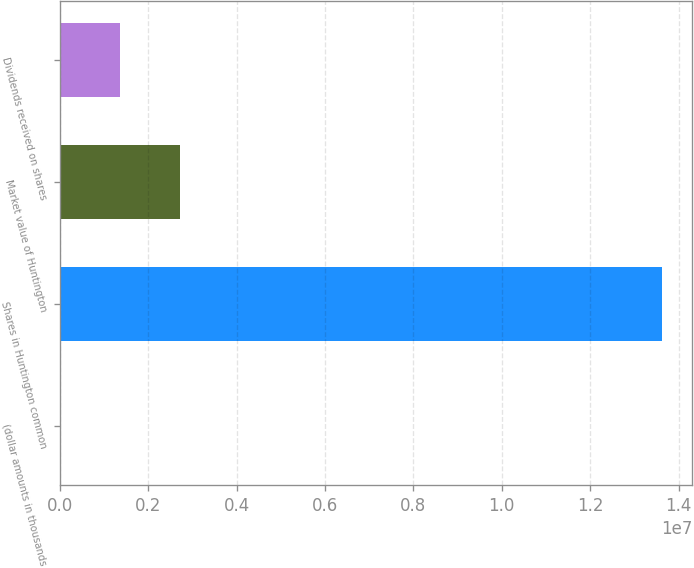Convert chart. <chart><loc_0><loc_0><loc_500><loc_500><bar_chart><fcel>(dollar amounts in thousands<fcel>Shares in Huntington common<fcel>Market value of Huntington<fcel>Dividends received on shares<nl><fcel>2013<fcel>1.36244e+07<fcel>2.7265e+06<fcel>1.36425e+06<nl></chart> 